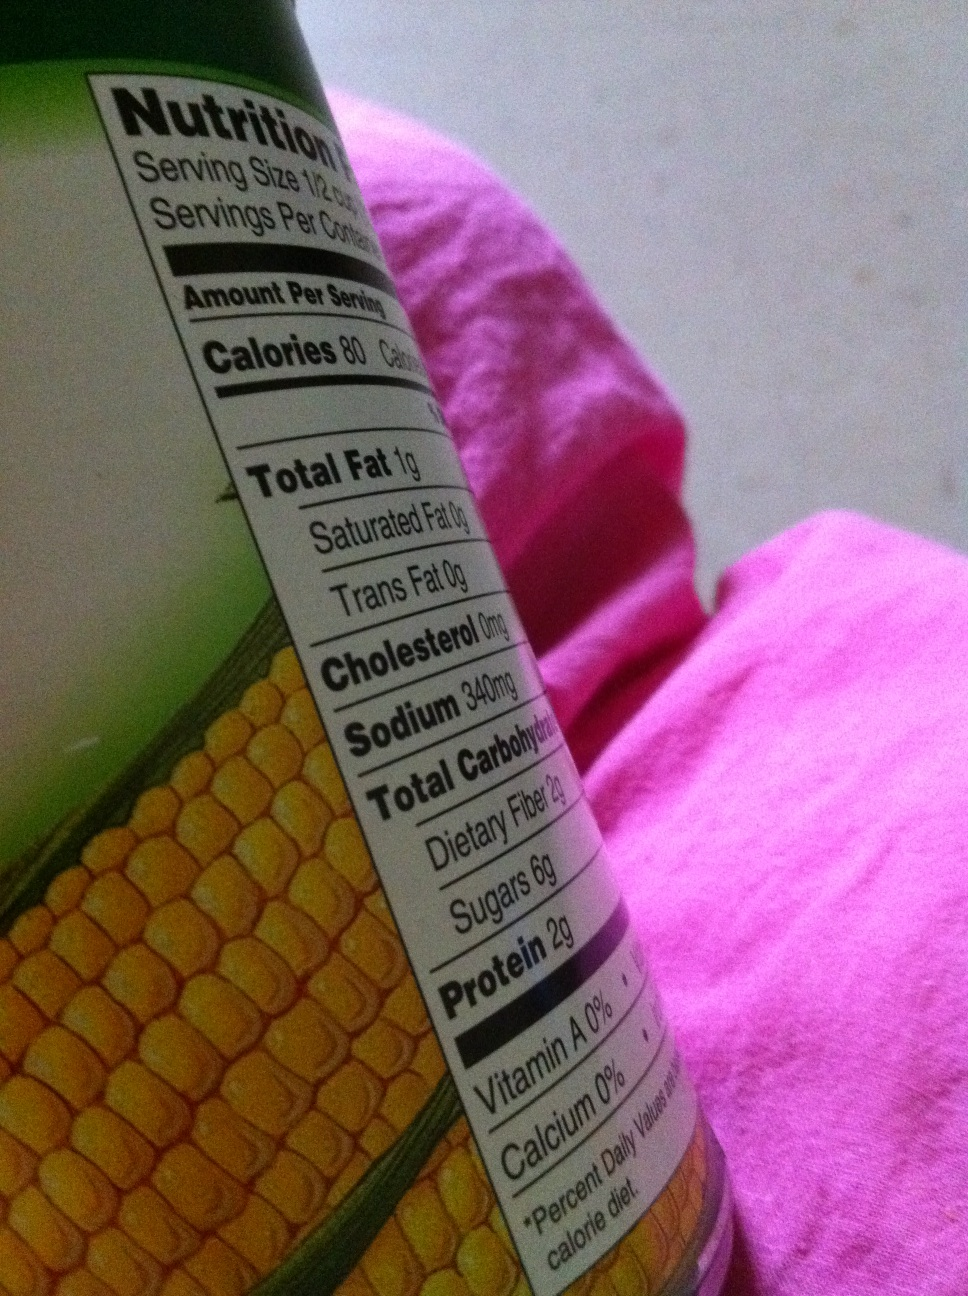What is this can? from Vizwiz This image shows the nutritional label on a can, indicating it likely contains a food item. The label mentions 'Total Carbohydrate' and dietary fiber content which, along with the partial depiction of corn kernels on the label, suggests the can may contain corn. However, without seeing the full label, including the product name and description, a definitive identification cannot be made. 